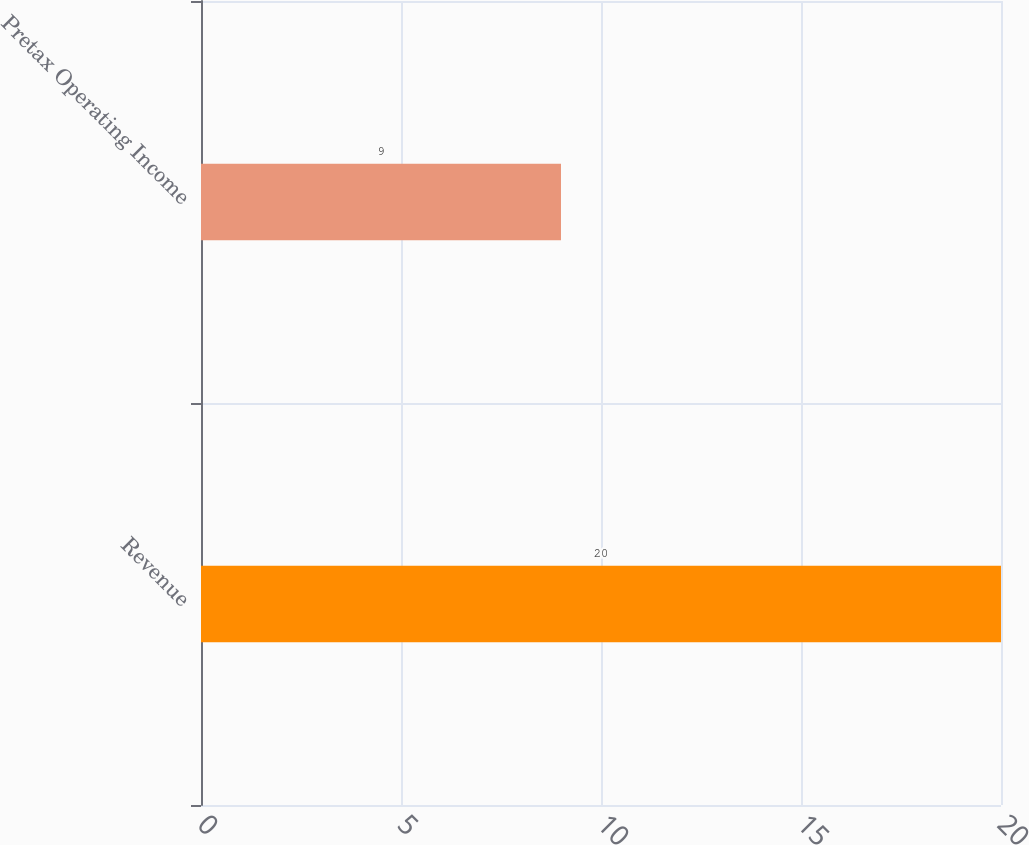Convert chart to OTSL. <chart><loc_0><loc_0><loc_500><loc_500><bar_chart><fcel>Revenue<fcel>Pretax Operating Income<nl><fcel>20<fcel>9<nl></chart> 